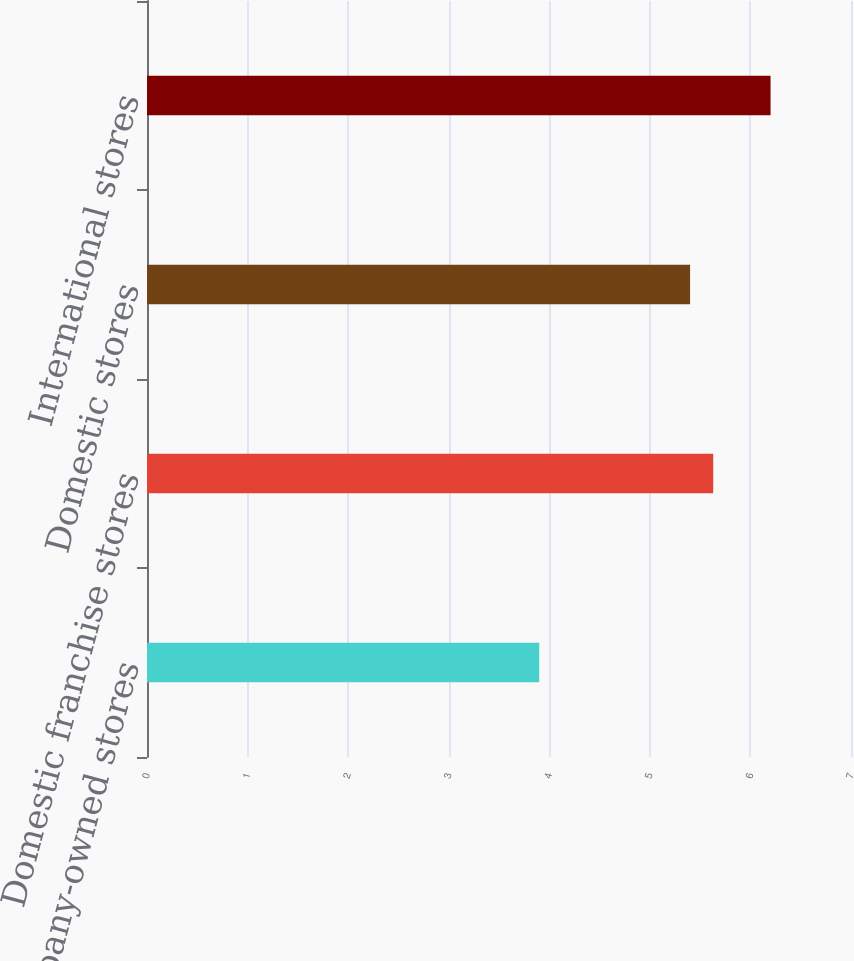<chart> <loc_0><loc_0><loc_500><loc_500><bar_chart><fcel>Domestic Company-owned stores<fcel>Domestic franchise stores<fcel>Domestic stores<fcel>International stores<nl><fcel>3.9<fcel>5.63<fcel>5.4<fcel>6.2<nl></chart> 